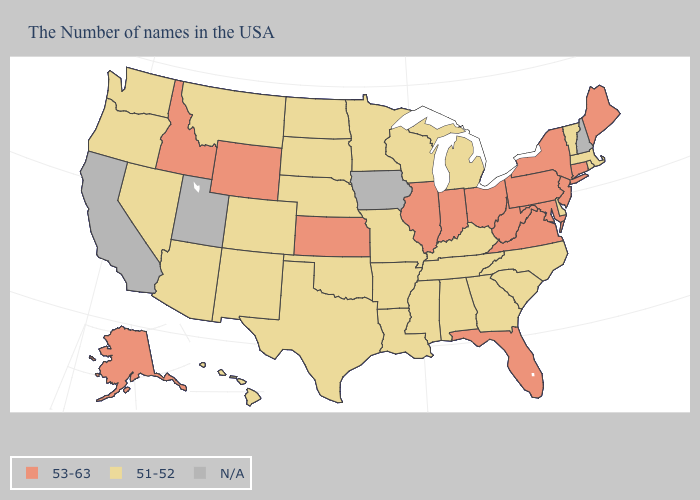Name the states that have a value in the range N/A?
Write a very short answer. New Hampshire, Iowa, Utah, California. What is the value of Missouri?
Concise answer only. 51-52. Which states have the lowest value in the West?
Be succinct. Colorado, New Mexico, Montana, Arizona, Nevada, Washington, Oregon, Hawaii. Which states hav the highest value in the West?
Be succinct. Wyoming, Idaho, Alaska. Does Michigan have the highest value in the USA?
Write a very short answer. No. Name the states that have a value in the range N/A?
Short answer required. New Hampshire, Iowa, Utah, California. Name the states that have a value in the range 53-63?
Concise answer only. Maine, Connecticut, New York, New Jersey, Maryland, Pennsylvania, Virginia, West Virginia, Ohio, Florida, Indiana, Illinois, Kansas, Wyoming, Idaho, Alaska. What is the value of North Carolina?
Answer briefly. 51-52. Is the legend a continuous bar?
Short answer required. No. What is the highest value in the Northeast ?
Be succinct. 53-63. What is the lowest value in states that border New Hampshire?
Concise answer only. 51-52. Which states have the lowest value in the USA?
Write a very short answer. Massachusetts, Rhode Island, Vermont, Delaware, North Carolina, South Carolina, Georgia, Michigan, Kentucky, Alabama, Tennessee, Wisconsin, Mississippi, Louisiana, Missouri, Arkansas, Minnesota, Nebraska, Oklahoma, Texas, South Dakota, North Dakota, Colorado, New Mexico, Montana, Arizona, Nevada, Washington, Oregon, Hawaii. Name the states that have a value in the range N/A?
Answer briefly. New Hampshire, Iowa, Utah, California. 